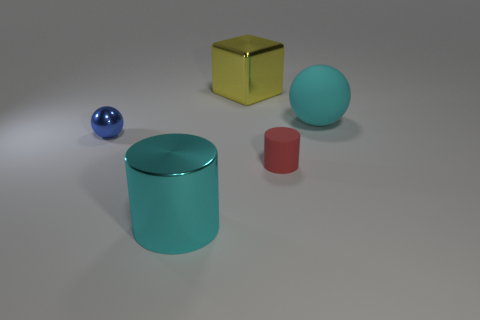Add 3 yellow metal objects. How many objects exist? 8 Subtract all balls. How many objects are left? 3 Add 4 big shiny cylinders. How many big shiny cylinders exist? 5 Subtract 0 brown blocks. How many objects are left? 5 Subtract all yellow things. Subtract all big yellow cubes. How many objects are left? 3 Add 5 yellow metal blocks. How many yellow metal blocks are left? 6 